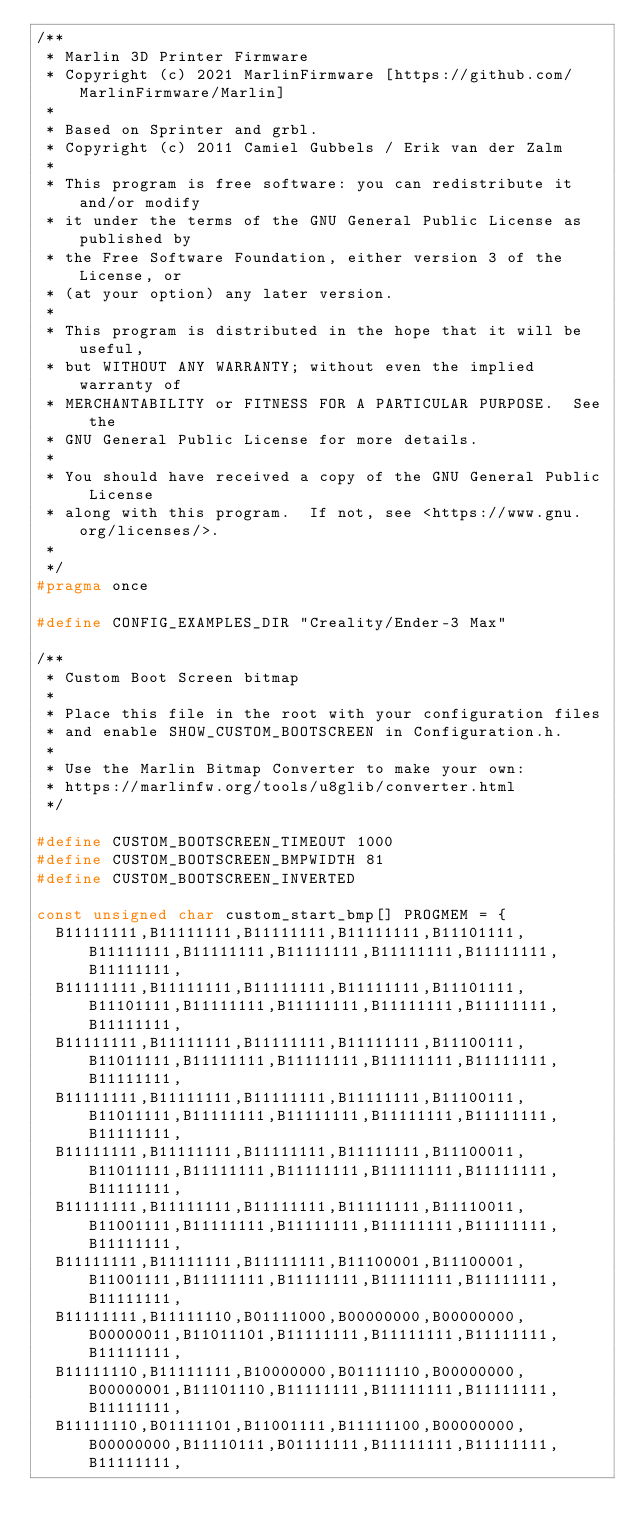<code> <loc_0><loc_0><loc_500><loc_500><_C_>/**
 * Marlin 3D Printer Firmware
 * Copyright (c) 2021 MarlinFirmware [https://github.com/MarlinFirmware/Marlin]
 *
 * Based on Sprinter and grbl.
 * Copyright (c) 2011 Camiel Gubbels / Erik van der Zalm
 *
 * This program is free software: you can redistribute it and/or modify
 * it under the terms of the GNU General Public License as published by
 * the Free Software Foundation, either version 3 of the License, or
 * (at your option) any later version.
 *
 * This program is distributed in the hope that it will be useful,
 * but WITHOUT ANY WARRANTY; without even the implied warranty of
 * MERCHANTABILITY or FITNESS FOR A PARTICULAR PURPOSE.  See the
 * GNU General Public License for more details.
 *
 * You should have received a copy of the GNU General Public License
 * along with this program.  If not, see <https://www.gnu.org/licenses/>.
 *
 */
#pragma once

#define CONFIG_EXAMPLES_DIR "Creality/Ender-3 Max"

/**
 * Custom Boot Screen bitmap
 *
 * Place this file in the root with your configuration files
 * and enable SHOW_CUSTOM_BOOTSCREEN in Configuration.h.
 *
 * Use the Marlin Bitmap Converter to make your own:
 * https://marlinfw.org/tools/u8glib/converter.html
 */

#define CUSTOM_BOOTSCREEN_TIMEOUT 1000
#define CUSTOM_BOOTSCREEN_BMPWIDTH 81
#define CUSTOM_BOOTSCREEN_INVERTED

const unsigned char custom_start_bmp[] PROGMEM = {
  B11111111,B11111111,B11111111,B11111111,B11101111,B11111111,B11111111,B11111111,B11111111,B11111111,B11111111,
  B11111111,B11111111,B11111111,B11111111,B11101111,B11101111,B11111111,B11111111,B11111111,B11111111,B11111111,
  B11111111,B11111111,B11111111,B11111111,B11100111,B11011111,B11111111,B11111111,B11111111,B11111111,B11111111,
  B11111111,B11111111,B11111111,B11111111,B11100111,B11011111,B11111111,B11111111,B11111111,B11111111,B11111111,
  B11111111,B11111111,B11111111,B11111111,B11100011,B11011111,B11111111,B11111111,B11111111,B11111111,B11111111,
  B11111111,B11111111,B11111111,B11111111,B11110011,B11001111,B11111111,B11111111,B11111111,B11111111,B11111111,
  B11111111,B11111111,B11111111,B11100001,B11100001,B11001111,B11111111,B11111111,B11111111,B11111111,B11111111,
  B11111111,B11111110,B01111000,B00000000,B00000000,B00000011,B11011101,B11111111,B11111111,B11111111,B11111111,
  B11111110,B11111111,B10000000,B01111110,B00000000,B00000001,B11101110,B11111111,B11111111,B11111111,B11111111,
  B11111110,B01111101,B11001111,B11111100,B00000000,B00000000,B11110111,B01111111,B11111111,B11111111,B11111111,</code> 